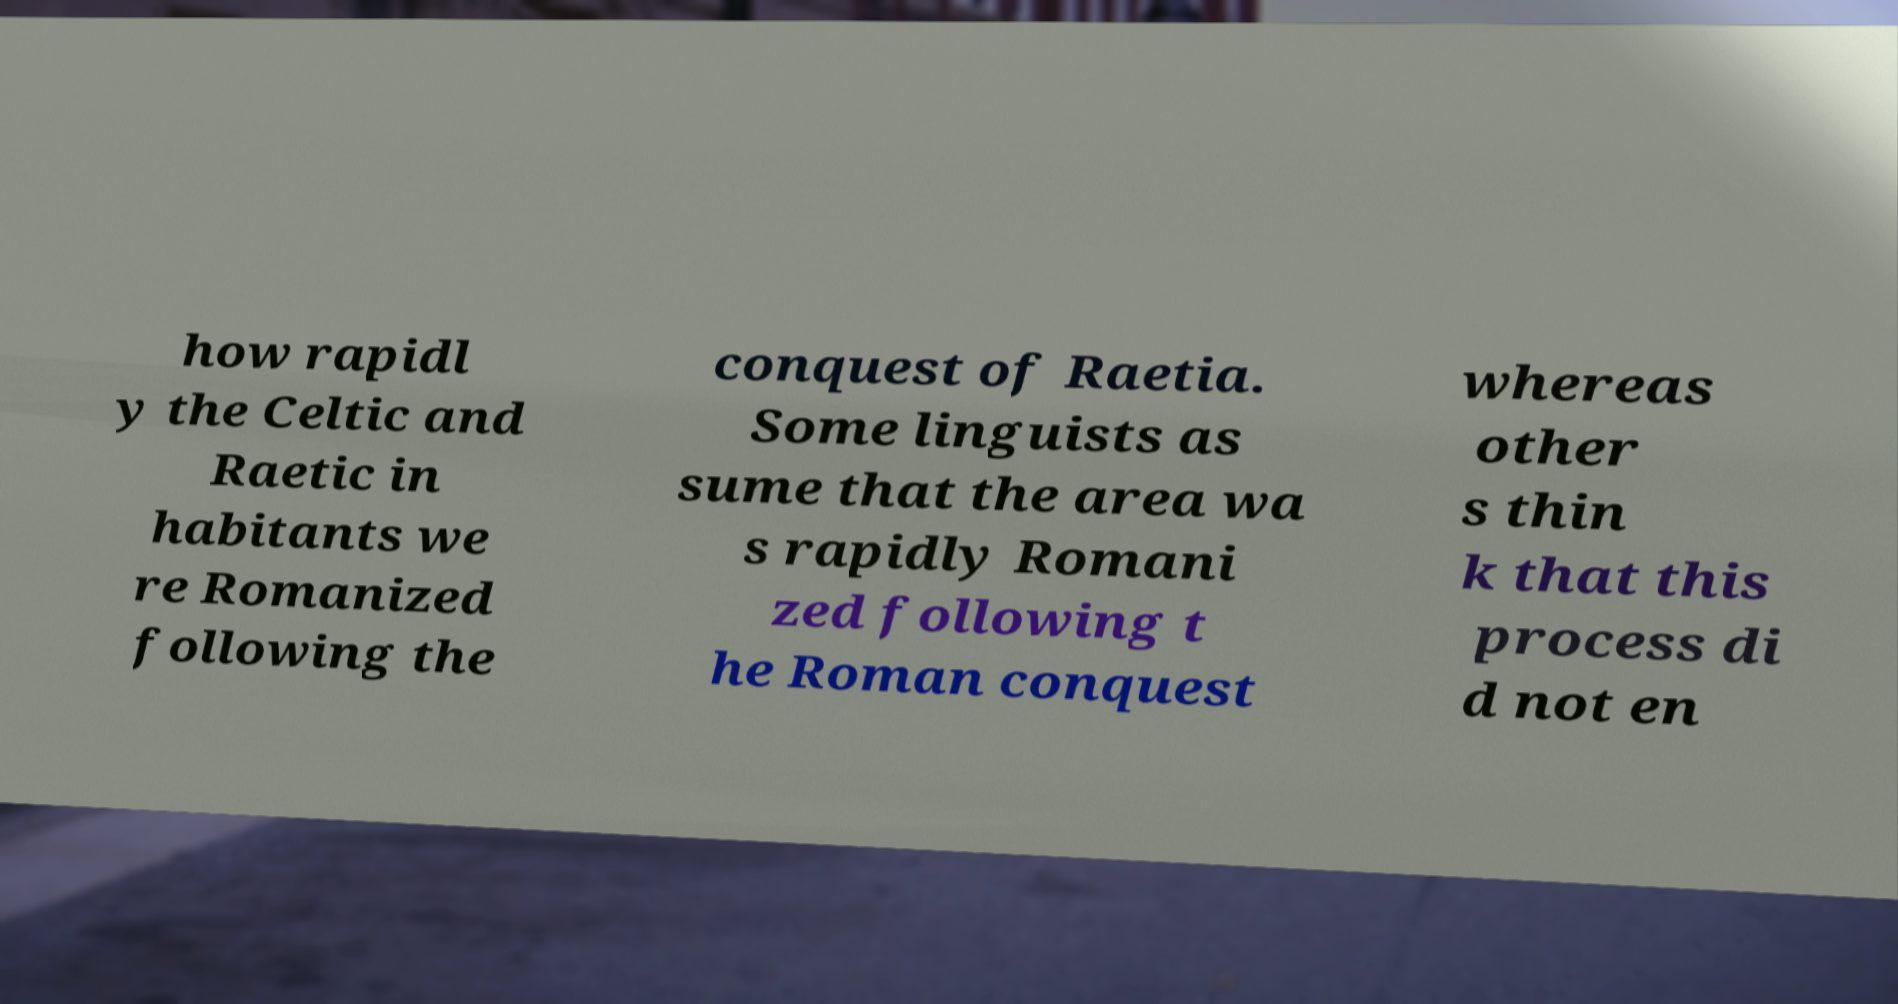There's text embedded in this image that I need extracted. Can you transcribe it verbatim? how rapidl y the Celtic and Raetic in habitants we re Romanized following the conquest of Raetia. Some linguists as sume that the area wa s rapidly Romani zed following t he Roman conquest whereas other s thin k that this process di d not en 